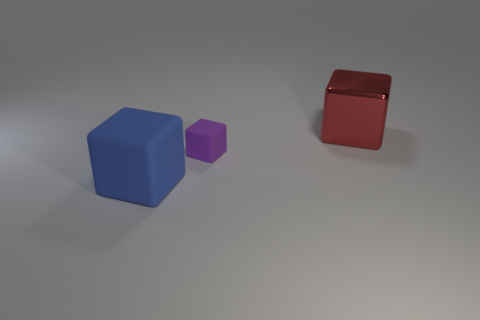Is there anything else that is the same size as the purple matte object?
Make the answer very short. No. Is the size of the rubber cube that is behind the large blue matte thing the same as the cube on the right side of the purple matte object?
Give a very brief answer. No. What is the shape of the thing that is behind the large matte thing and in front of the large metal object?
Keep it short and to the point. Cube. Is there another tiny object made of the same material as the tiny thing?
Provide a short and direct response. No. Is the material of the large thing in front of the metallic object the same as the big object that is behind the big blue cube?
Ensure brevity in your answer.  No. Is the number of tiny purple matte blocks greater than the number of purple rubber cylinders?
Your response must be concise. Yes. There is a large object on the right side of the cube that is in front of the matte object that is to the right of the big blue block; what is its color?
Make the answer very short. Red. There is a matte thing behind the blue matte thing; does it have the same color as the thing that is behind the tiny matte object?
Make the answer very short. No. There is a large cube that is right of the big blue matte thing; how many big cubes are in front of it?
Your answer should be compact. 1. Are there any blue rubber blocks?
Ensure brevity in your answer.  Yes. 